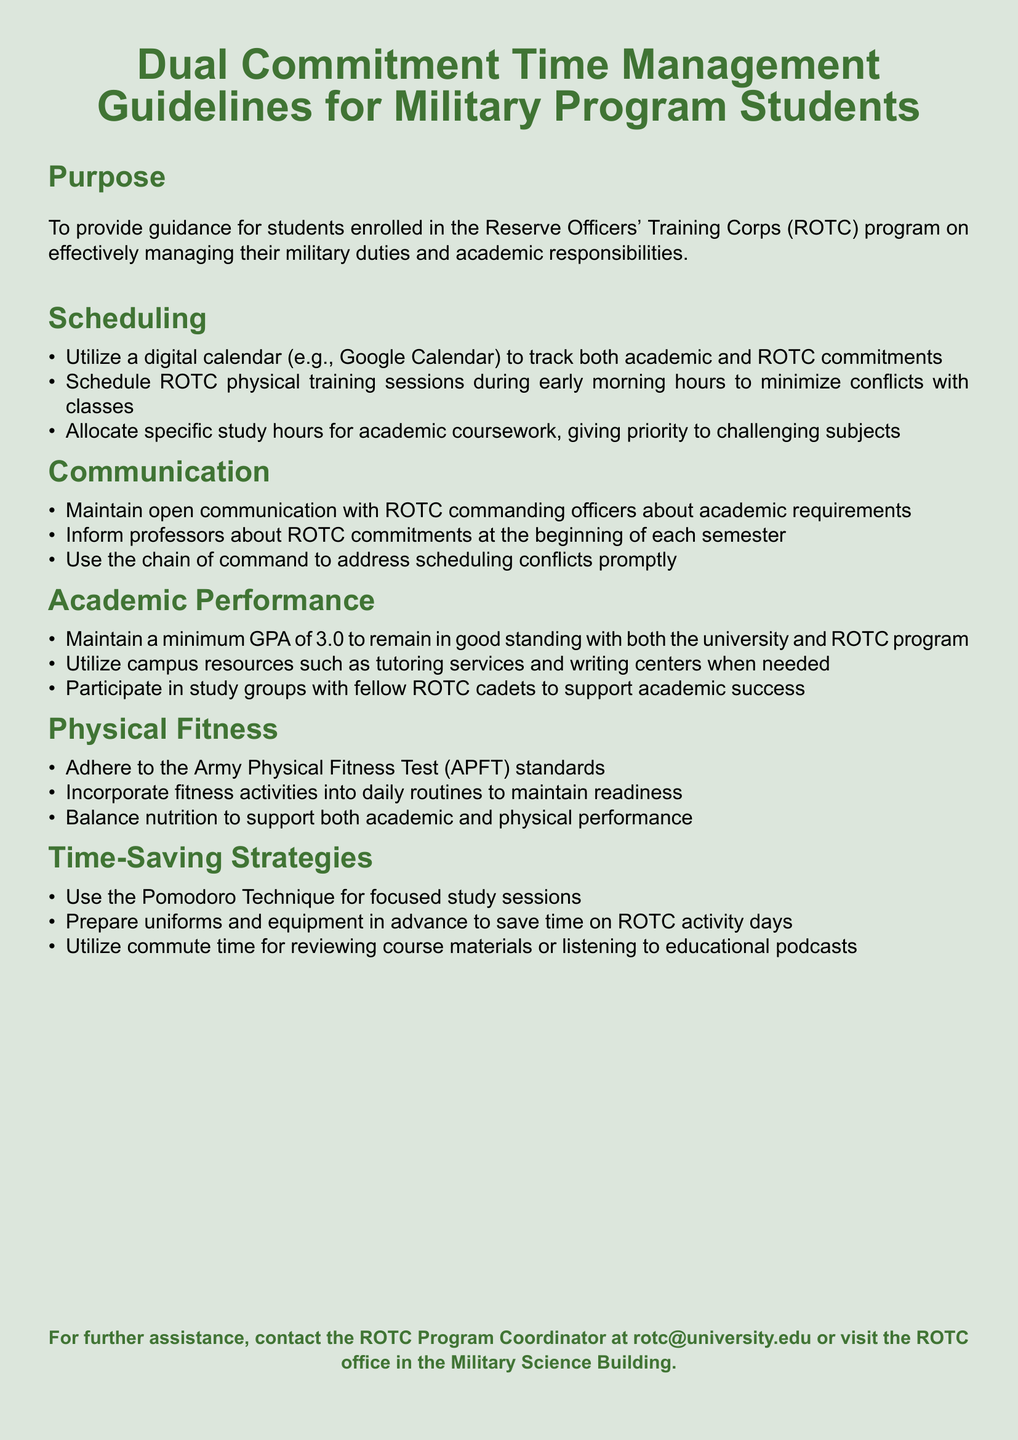What is the minimum GPA required? The document states that students must maintain a minimum GPA of 3.0 to remain in good standing with both the university and ROTC program.
Answer: 3.0 What is the recommended tool for scheduling commitments? It is suggested to utilize a digital calendar such as Google Calendar to track both academic and ROTC commitments.
Answer: Google Calendar What is the purpose of the guidelines? The purpose is to provide guidance for students enrolled in the ROTC program on effectively managing their military duties and academic responsibilities.
Answer: To provide guidance What fitness test standards should be adhered to? The document specifies adherence to the Army Physical Fitness Test (APFT) standards.
Answer: Army Physical Fitness Test (APFT) What technique is suggested for focused study sessions? The Pomodoro Technique is recommended for focused study sessions.
Answer: Pomodoro Technique How should students communicate ROTC commitments? Students are advised to inform professors about their ROTC commitments at the beginning of each semester.
Answer: Inform professors What type of groups should students participate in for academic success? Students are encouraged to participate in study groups with fellow ROTC cadets.
Answer: Study groups What is a time-saving strategy mentioned in the document? Preparing uniforms and equipment in advance is listed as a time-saving strategy for ROTC activity days.
Answer: Prepare uniforms What is one way to incorporate fitness into daily routines? The document recommends incorporating fitness activities into daily routines to maintain readiness.
Answer: Incorporate fitness activities 